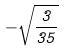Convert formula to latex. <formula><loc_0><loc_0><loc_500><loc_500>- \sqrt { \frac { 3 } { 3 5 } }</formula> 